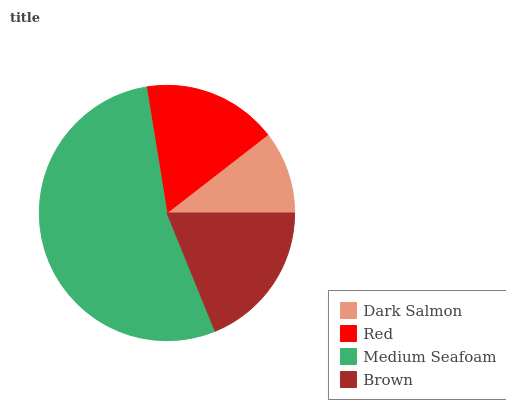Is Dark Salmon the minimum?
Answer yes or no. Yes. Is Medium Seafoam the maximum?
Answer yes or no. Yes. Is Red the minimum?
Answer yes or no. No. Is Red the maximum?
Answer yes or no. No. Is Red greater than Dark Salmon?
Answer yes or no. Yes. Is Dark Salmon less than Red?
Answer yes or no. Yes. Is Dark Salmon greater than Red?
Answer yes or no. No. Is Red less than Dark Salmon?
Answer yes or no. No. Is Brown the high median?
Answer yes or no. Yes. Is Red the low median?
Answer yes or no. Yes. Is Medium Seafoam the high median?
Answer yes or no. No. Is Dark Salmon the low median?
Answer yes or no. No. 